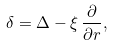<formula> <loc_0><loc_0><loc_500><loc_500>\delta = \Delta - \xi \, \frac { \partial } { \partial r } ,</formula> 